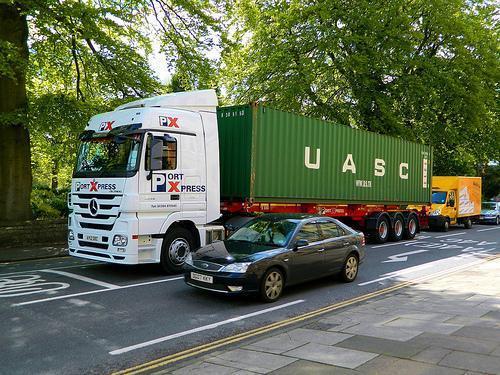How many vehicles?
Give a very brief answer. 4. 